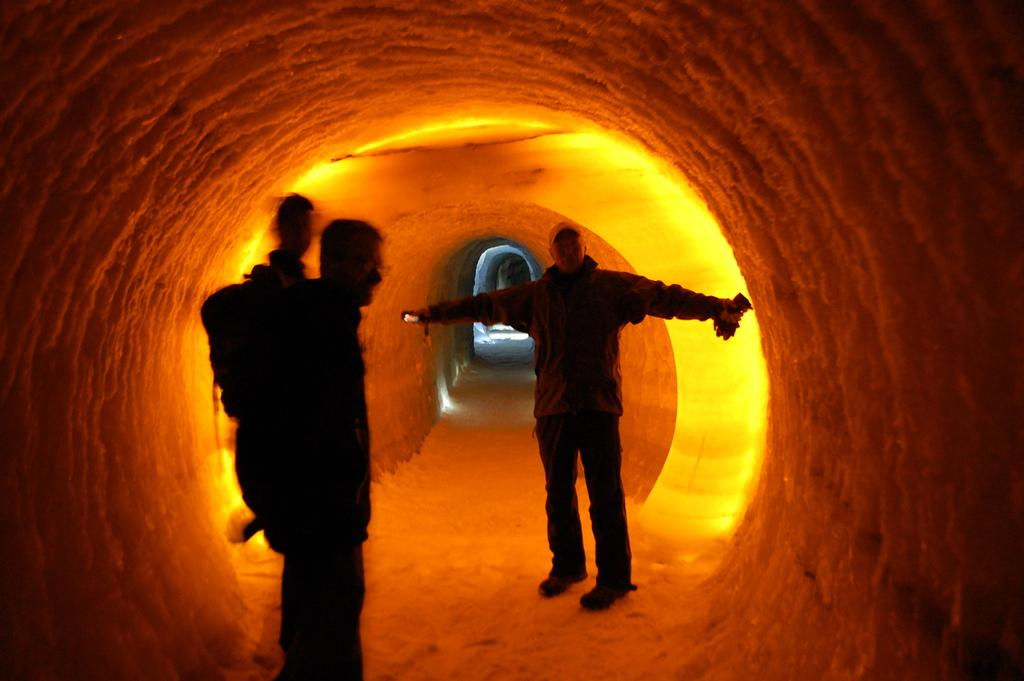How many people are in the image? There are three people in the image. Where are the people standing in the image? The people are standing under a cave. What can be seen inside the cave? There is yellow light visible in the cave. What type of sack is hanging from the ceiling of the cave in the image? There is no sack visible in the image; only the people and the cave are present. 